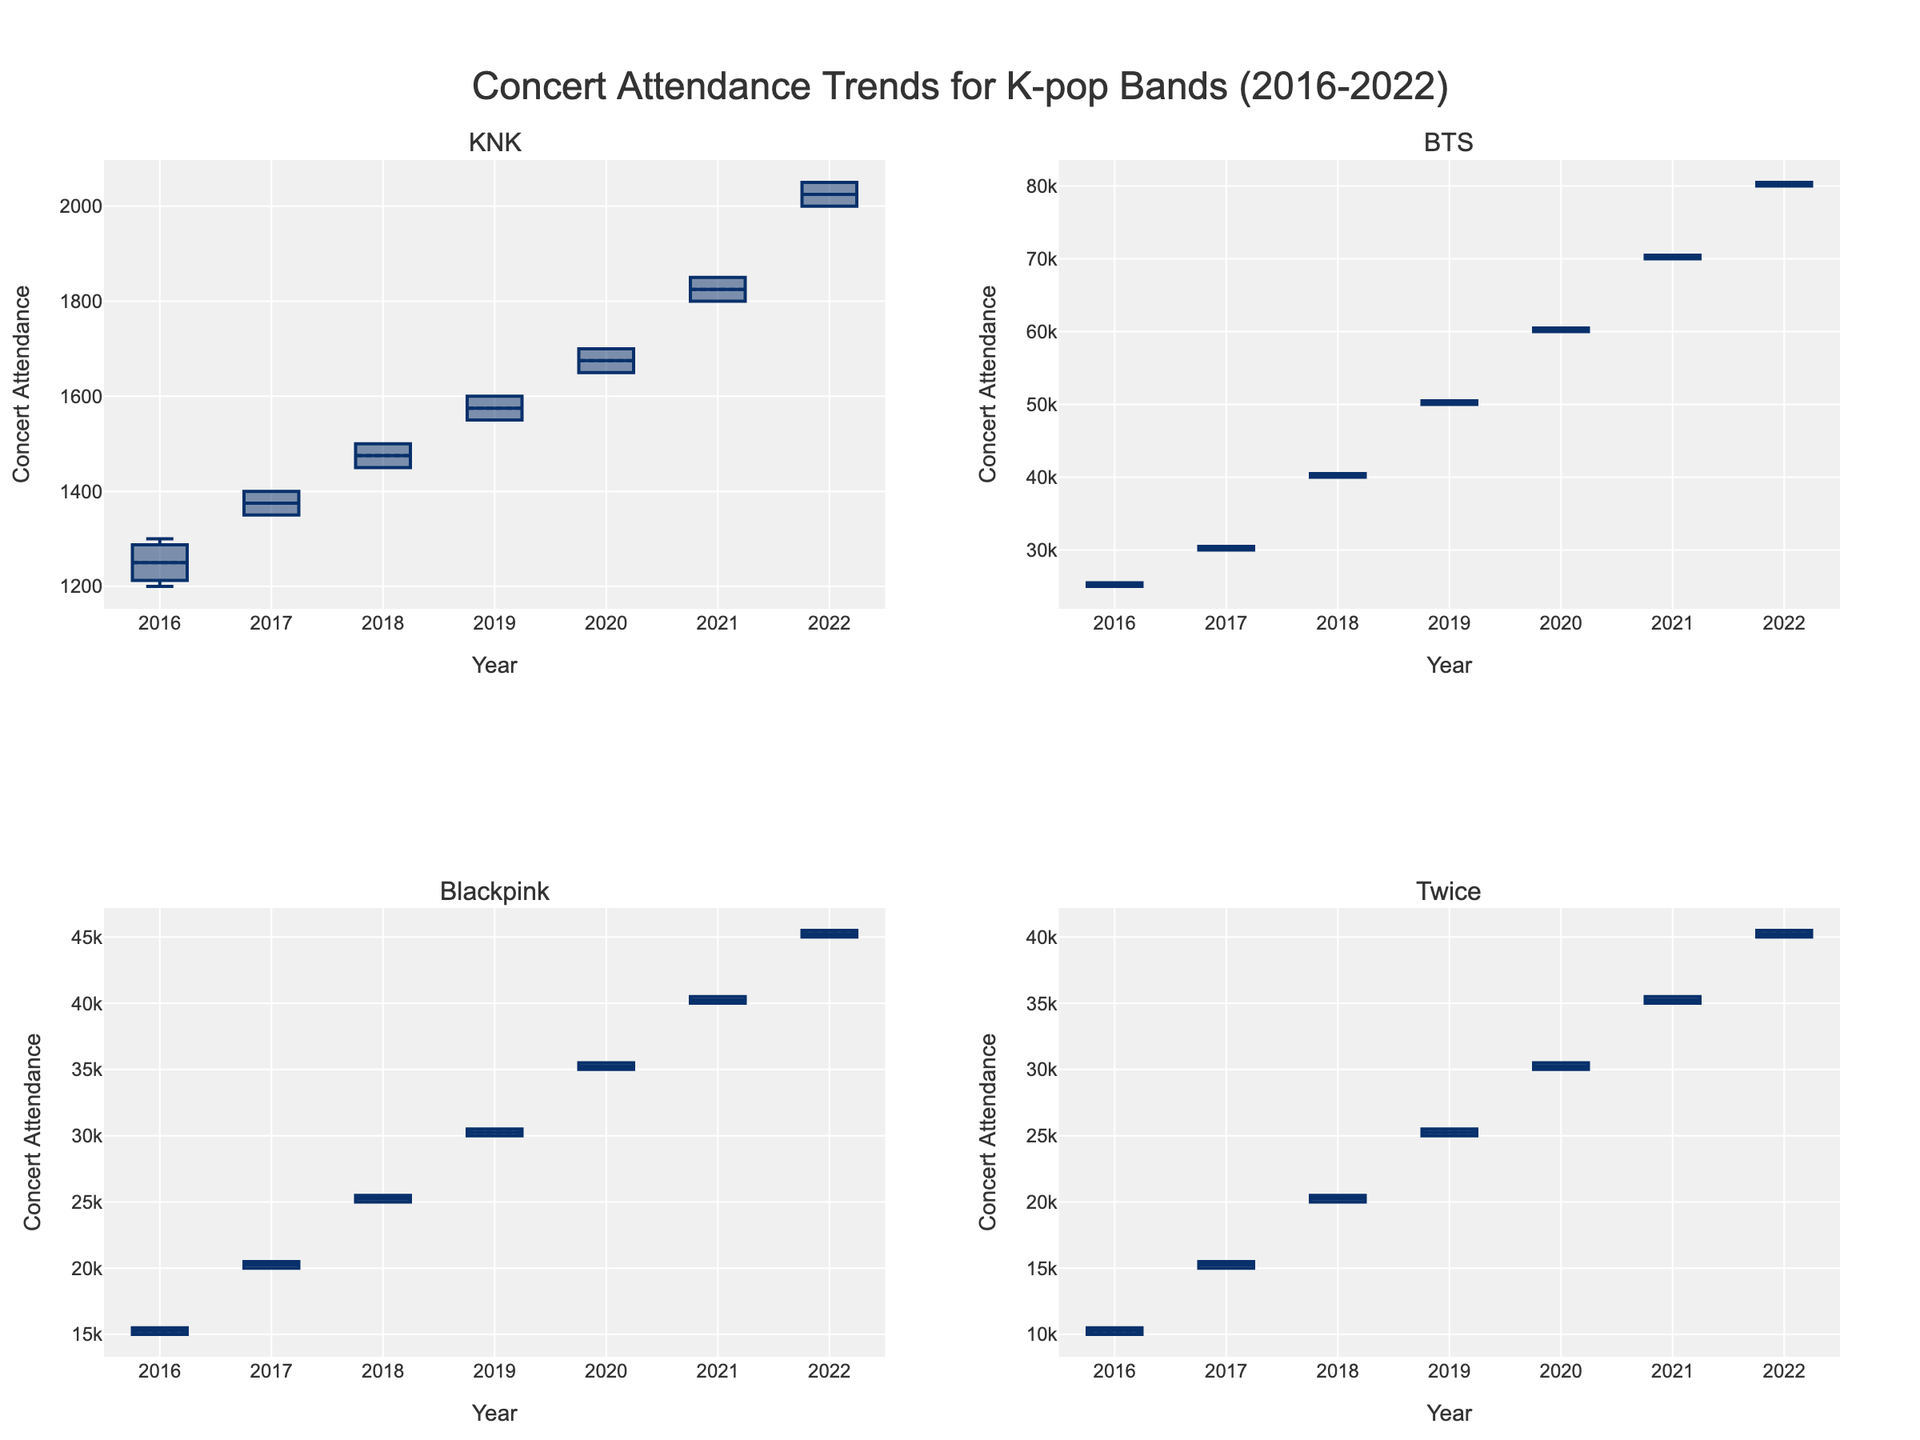What is the title of the figure? The title is displayed at the top center of the figure and can be read directly from the plot.
Answer: Concert Attendance Trends for K-pop Bands (2016-2022) Which band's subplot is located in the bottom right corner? The subplot titles help in identifying the respective bands, and the bottom right corner is the fourth subplot.
Answer: Twice What year shows the highest concert attendance for KNK? By examining the highest points in the KNK subplot for each year, the year with the highest attendance is identified.
Answer: 2022 How does the concert attendance for KNK in 2016 compare to BTS in 2016? Compare the medians of the box plots for both bands in 2016, which can be observed as line marks inside the boxes.
Answer: BTS has a much higher attendance than KNK in 2016 What is the overall trend in concert attendance for Blackpink from 2016 to 2022? By inspecting the box plot for Blackpink across the years, the trend can be observed based on the rising positions of the medians.
Answer: Increasing Which band has the widest range of concert attendance values in 2021? The range can be observed from the length of the box and the whiskers; the wider range indicates this clearly.
Answer: BTS How does the median concert attendance for 2020 compare across all four bands? Compare the median lines within the boxes for the year 2020 across all subplots.
Answer: BTS > Blackpink > Twice > KNK What is the color used for the band KNK in the plot? This can be deduced from the subplot color for KNK, which is consistent across the box plots therein.
Answer: A light reddish shade Are there any outliers visible in the concert attendance for Twice in 2019? Outliers are represented as individual points outside the whiskers in the boxplots; check the subplot for Twice in 2019.
Answer: No Which bands show a significant increase in concert attendance every year from 2016 to 2022? Look at the general uptrend across years in the subplots to identify which bands show consistent yearly increases.
Answer: BTS and Blackpink 